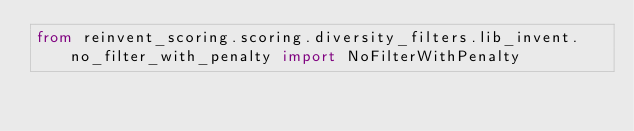Convert code to text. <code><loc_0><loc_0><loc_500><loc_500><_Python_>from reinvent_scoring.scoring.diversity_filters.lib_invent.no_filter_with_penalty import NoFilterWithPenalty
</code> 